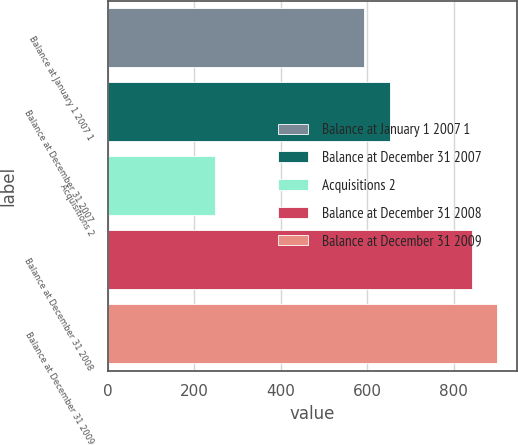Convert chart. <chart><loc_0><loc_0><loc_500><loc_500><bar_chart><fcel>Balance at January 1 2007 1<fcel>Balance at December 31 2007<fcel>Acquisitions 2<fcel>Balance at December 31 2008<fcel>Balance at December 31 2009<nl><fcel>593<fcel>652.3<fcel>248<fcel>841<fcel>900.3<nl></chart> 